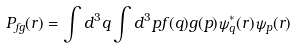Convert formula to latex. <formula><loc_0><loc_0><loc_500><loc_500>P _ { f g } ( { r } ) = \int d ^ { 3 } { q } \int d ^ { 3 } { p } f ( { q } ) g ( { p } ) \psi _ { q } ^ { * } ( { r } ) \psi _ { p } ( { r } )</formula> 